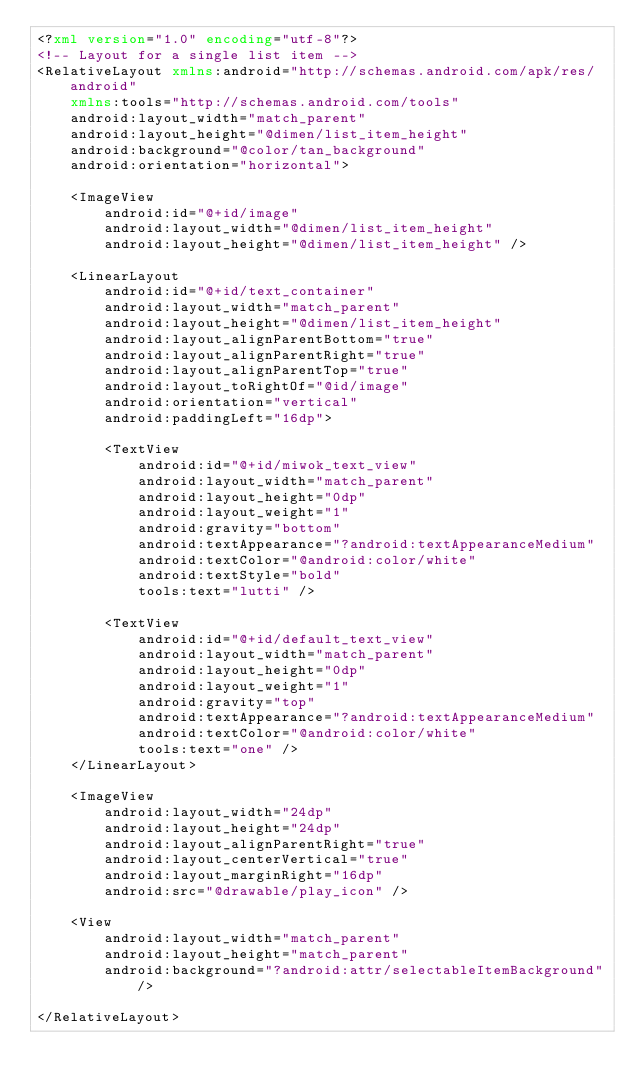<code> <loc_0><loc_0><loc_500><loc_500><_XML_><?xml version="1.0" encoding="utf-8"?>
<!-- Layout for a single list item -->
<RelativeLayout xmlns:android="http://schemas.android.com/apk/res/android"
    xmlns:tools="http://schemas.android.com/tools"
    android:layout_width="match_parent"
    android:layout_height="@dimen/list_item_height"
    android:background="@color/tan_background"
    android:orientation="horizontal">

    <ImageView
        android:id="@+id/image"
        android:layout_width="@dimen/list_item_height"
        android:layout_height="@dimen/list_item_height" />

    <LinearLayout
        android:id="@+id/text_container"
        android:layout_width="match_parent"
        android:layout_height="@dimen/list_item_height"
        android:layout_alignParentBottom="true"
        android:layout_alignParentRight="true"
        android:layout_alignParentTop="true"
        android:layout_toRightOf="@id/image"
        android:orientation="vertical"
        android:paddingLeft="16dp">

        <TextView
            android:id="@+id/miwok_text_view"
            android:layout_width="match_parent"
            android:layout_height="0dp"
            android:layout_weight="1"
            android:gravity="bottom"
            android:textAppearance="?android:textAppearanceMedium"
            android:textColor="@android:color/white"
            android:textStyle="bold"
            tools:text="lutti" />

        <TextView
            android:id="@+id/default_text_view"
            android:layout_width="match_parent"
            android:layout_height="0dp"
            android:layout_weight="1"
            android:gravity="top"
            android:textAppearance="?android:textAppearanceMedium"
            android:textColor="@android:color/white"
            tools:text="one" />
    </LinearLayout>

    <ImageView
        android:layout_width="24dp"
        android:layout_height="24dp"
        android:layout_alignParentRight="true"
        android:layout_centerVertical="true"
        android:layout_marginRight="16dp"
        android:src="@drawable/play_icon" />

    <View
        android:layout_width="match_parent"
        android:layout_height="match_parent"
        android:background="?android:attr/selectableItemBackground"/>

</RelativeLayout></code> 